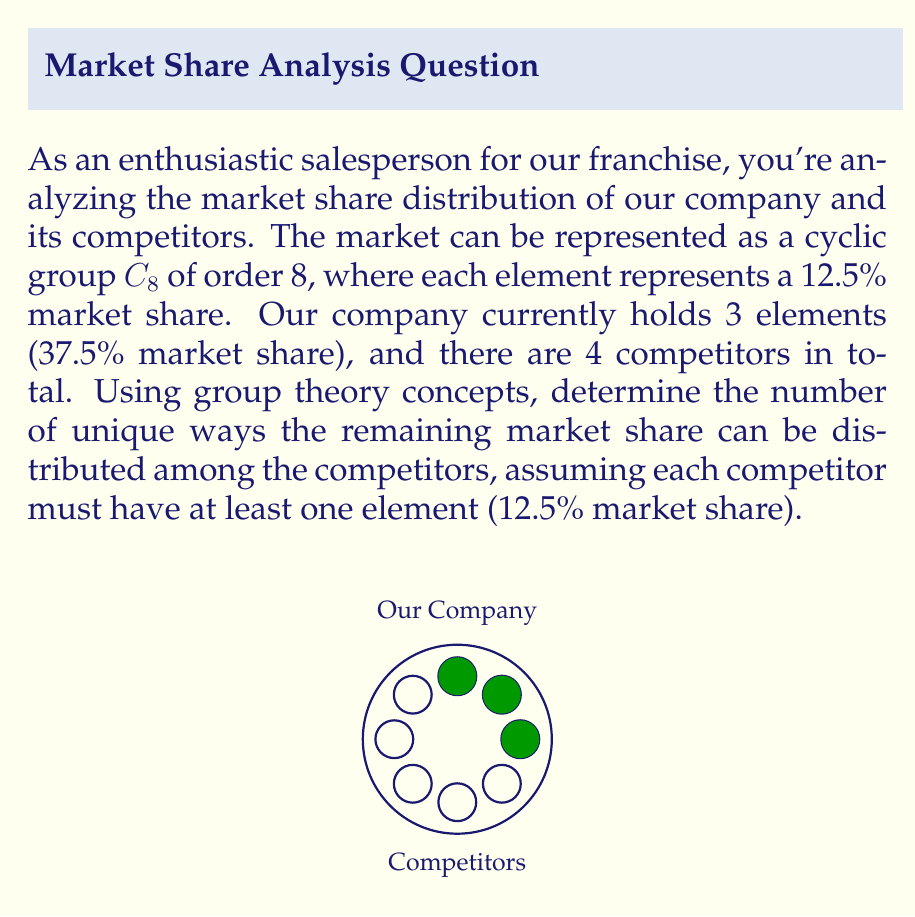Could you help me with this problem? Let's approach this step-by-step using group theory concepts:

1) The market is represented as a cyclic group $C_8$, which has 8 elements in total.

2) Our company holds 3 elements, leaving 5 elements to be distributed among 4 competitors.

3) This problem is equivalent to finding the number of ways to partition 5 into 4 positive integers, as each competitor must have at least one element.

4) In group theory, this is known as a composition of 5 into 4 parts.

5) The number of compositions of n into k parts is given by the binomial coefficient:

   $${n-1 \choose k-1}$$

6) In our case, n = 5 and k = 4, so we need to calculate:

   $${5-1 \choose 4-1} = {4 \choose 3}$$

7) We can calculate this using the formula:

   $${4 \choose 3} = \frac{4!}{3!(4-3)!} = \frac{4!}{3!1!}$$

8) Expanding this:
   
   $$\frac{4 \times 3 \times 2 \times 1}{(3 \times 2 \times 1)(1)} = \frac{24}{6} = 4$$

Therefore, there are 4 unique ways to distribute the remaining market share among the competitors.
Answer: 4 